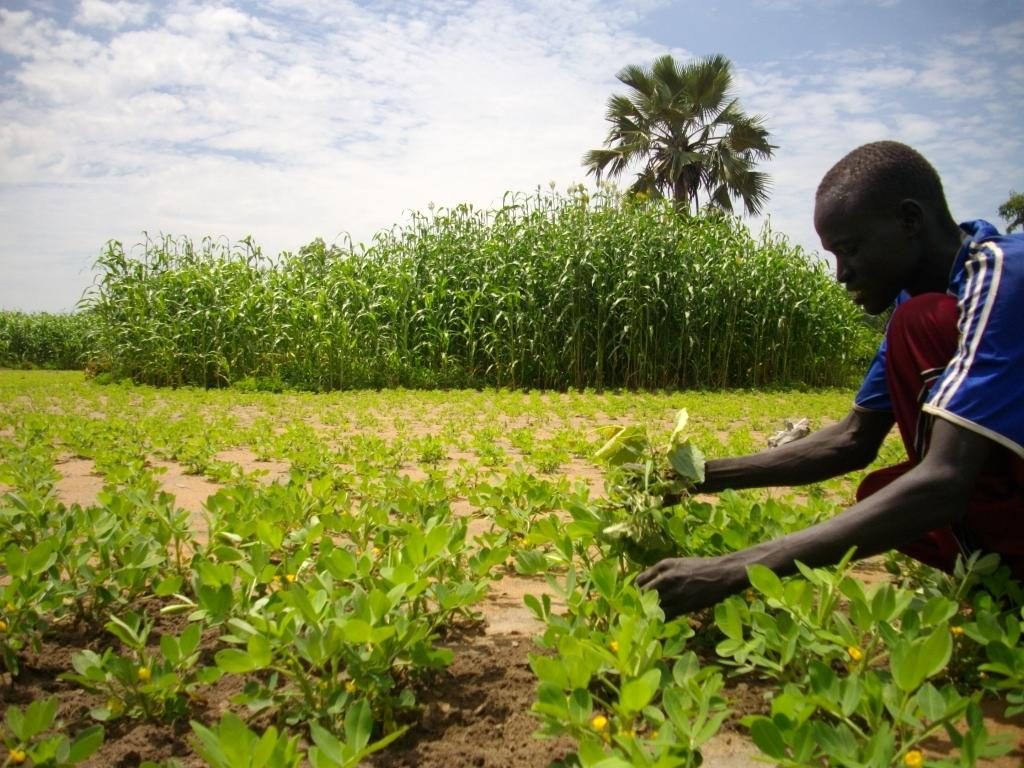What is the person in the image holding? The person in the image is holding plants. What else can be seen in the image besides the person holding plants? There are plants and trees visible in the image. How many worms can be seen jumping around the plants in the image? There are no worms visible in the image, and therefore no such activity can be observed. What type of tent is set up near the trees in the image? There is no tent present in the image. 